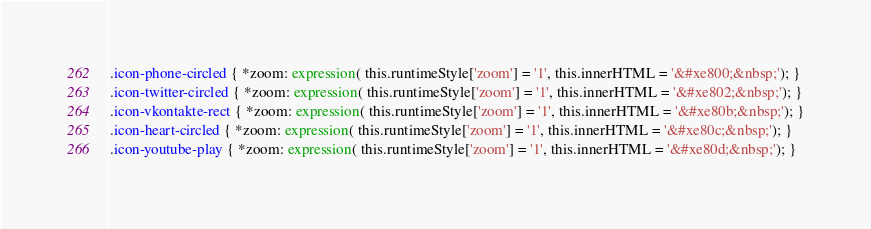<code> <loc_0><loc_0><loc_500><loc_500><_CSS_>
.icon-phone-circled { *zoom: expression( this.runtimeStyle['zoom'] = '1', this.innerHTML = '&#xe800;&nbsp;'); }
.icon-twitter-circled { *zoom: expression( this.runtimeStyle['zoom'] = '1', this.innerHTML = '&#xe802;&nbsp;'); }
.icon-vkontakte-rect { *zoom: expression( this.runtimeStyle['zoom'] = '1', this.innerHTML = '&#xe80b;&nbsp;'); }
.icon-heart-circled { *zoom: expression( this.runtimeStyle['zoom'] = '1', this.innerHTML = '&#xe80c;&nbsp;'); }
.icon-youtube-play { *zoom: expression( this.runtimeStyle['zoom'] = '1', this.innerHTML = '&#xe80d;&nbsp;'); }</code> 